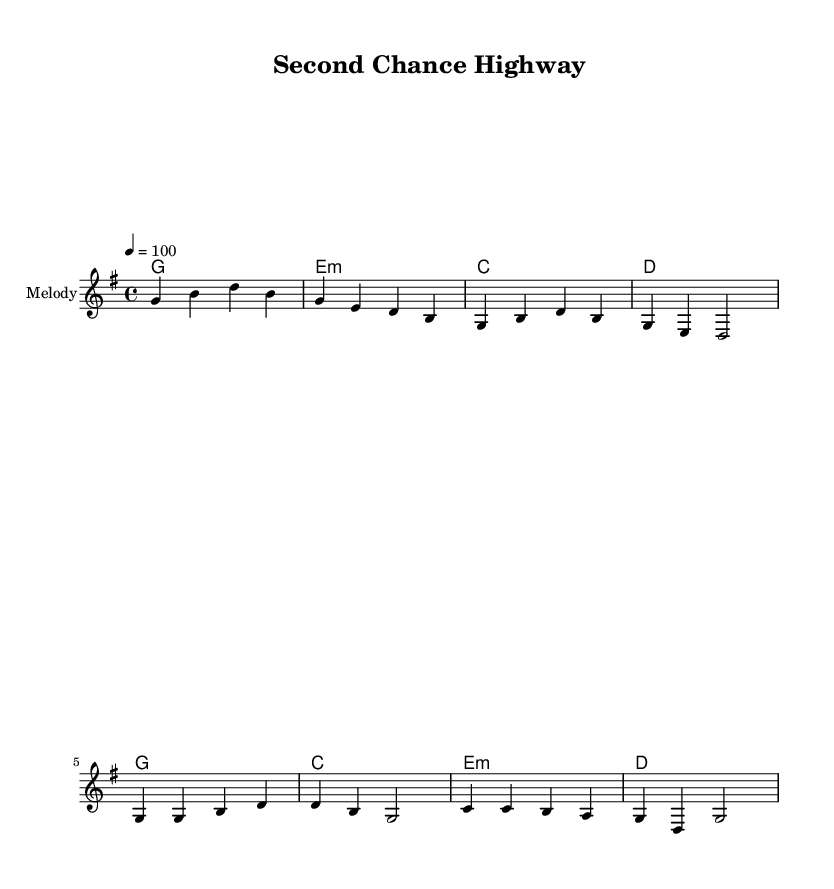What is the key signature of this music? The key signature is G major, which contains one sharp (F#). You can tell because the key signature is notated at the beginning of the score and indicates G major.
Answer: G major What is the time signature for this piece? The time signature is 4/4, which is indicated at the beginning of the score. It tells us there are four beats per measure and the quarter note gets one beat.
Answer: 4/4 What is the tempo marking for this song? The tempo marking indicates a speed of 100 beats per minute. It's shown in the score next to the word "tempo".
Answer: 100 How many measures are in the verse? The verse consists of four measures as seen from the section notated before the chorus. Each phrase of the verse has a set of four distinct measures.
Answer: 4 What are the primary themes of the lyrics? The primary themes include redemption and second chances, as indicated by the phrase "Second Chance Highway" in both the song title and the lyrics discussing mistakes and making a fresh start.
Answer: Redemption and second chances Which chords are used in the chorus? The chords used in the chorus are G, C, E minor, and D, directly noted in the harmonies section of the score where they align with the melody and lyrics.
Answer: G, C, E minor, D 